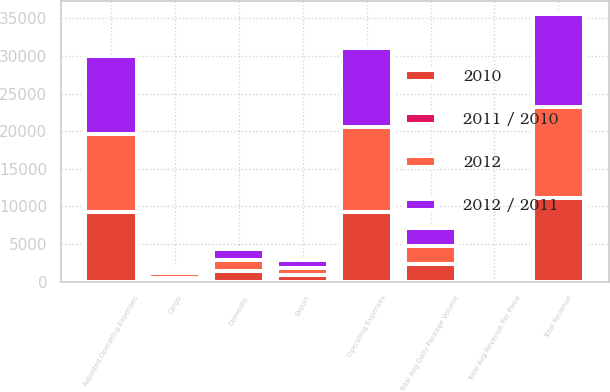Convert chart. <chart><loc_0><loc_0><loc_500><loc_500><stacked_bar_chart><ecel><fcel>Domestic<fcel>Export<fcel>Total Avg Daily Package Volume<fcel>Total Avg Revenue Per Piece<fcel>Cargo<fcel>Total Revenue<fcel>Operating Expenses<fcel>Adjusted Operating Expenses<nl><fcel>2012<fcel>1427<fcel>972<fcel>2399<fcel>19.13<fcel>560<fcel>12124<fcel>11255<fcel>10314<nl><fcel>2012 / 2011<fcel>1444<fcel>942<fcel>2386<fcel>19.28<fcel>565<fcel>12249<fcel>10540<fcel>10369<nl><fcel>2010<fcel>1403<fcel>885<fcel>2288<fcel>18.31<fcel>534<fcel>11133<fcel>9302<fcel>9260<nl><fcel>2011 / 2010<fcel>1.2<fcel>3.2<fcel>0.5<fcel>0.8<fcel>0.9<fcel>1<fcel>6.8<fcel>0.5<nl></chart> 